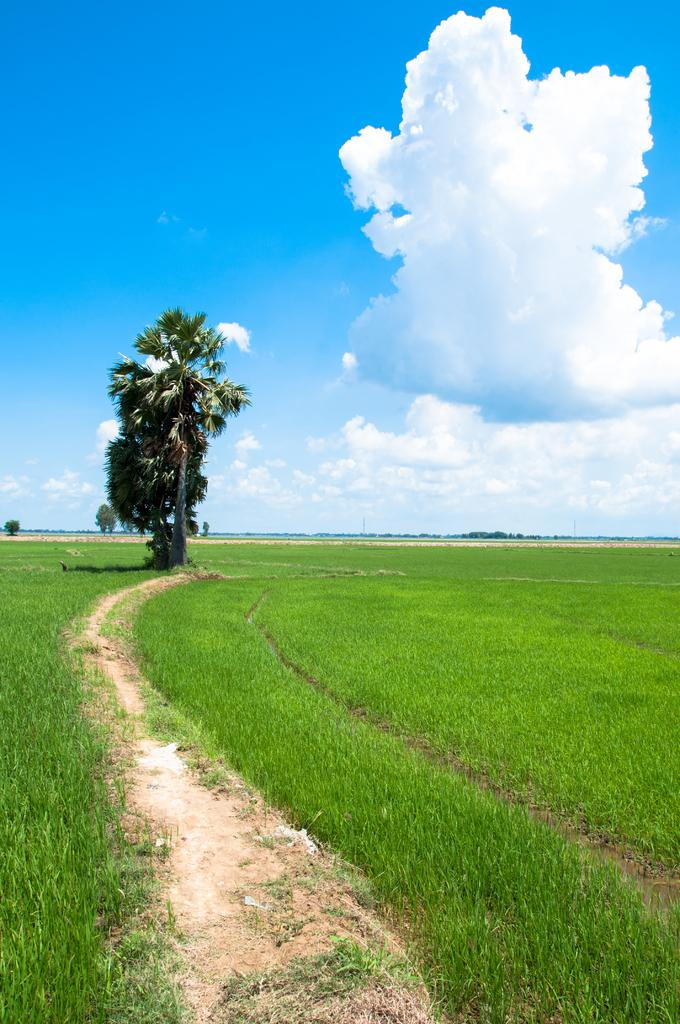What is at the bottom of the image? There is a path at the bottom of the image. What can be seen on both sides of the path? There are plants on both sides of the path. What is visible in the background of the image? There are trees and plants in the background of the image. How would you describe the sky in the image? The sky is blue and has clouds in it. What type of doctor can be seen examining a patient in the image? There is no doctor or patient present in the image; it features a path, plants, trees, and a blue sky with clouds. What part of the image is in motion? There is no motion depicted in the image; it is a static representation of a path, plants, trees, and the sky. 